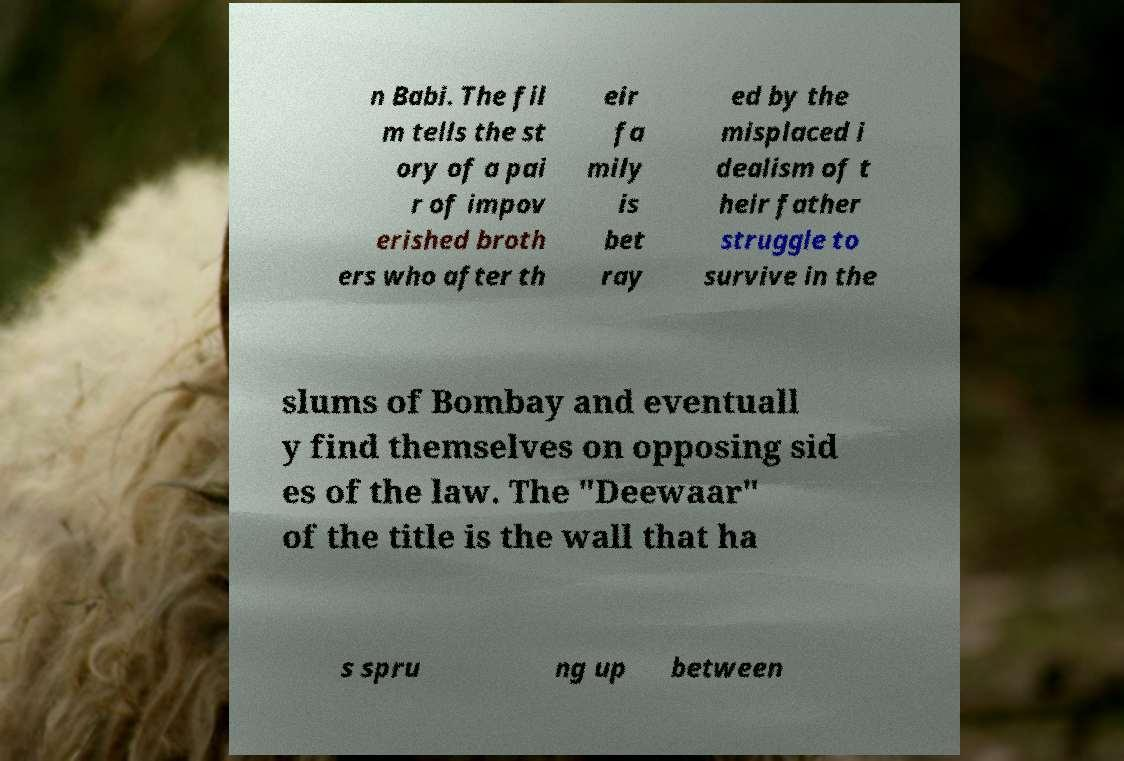Can you read and provide the text displayed in the image?This photo seems to have some interesting text. Can you extract and type it out for me? n Babi. The fil m tells the st ory of a pai r of impov erished broth ers who after th eir fa mily is bet ray ed by the misplaced i dealism of t heir father struggle to survive in the slums of Bombay and eventuall y find themselves on opposing sid es of the law. The "Deewaar" of the title is the wall that ha s spru ng up between 